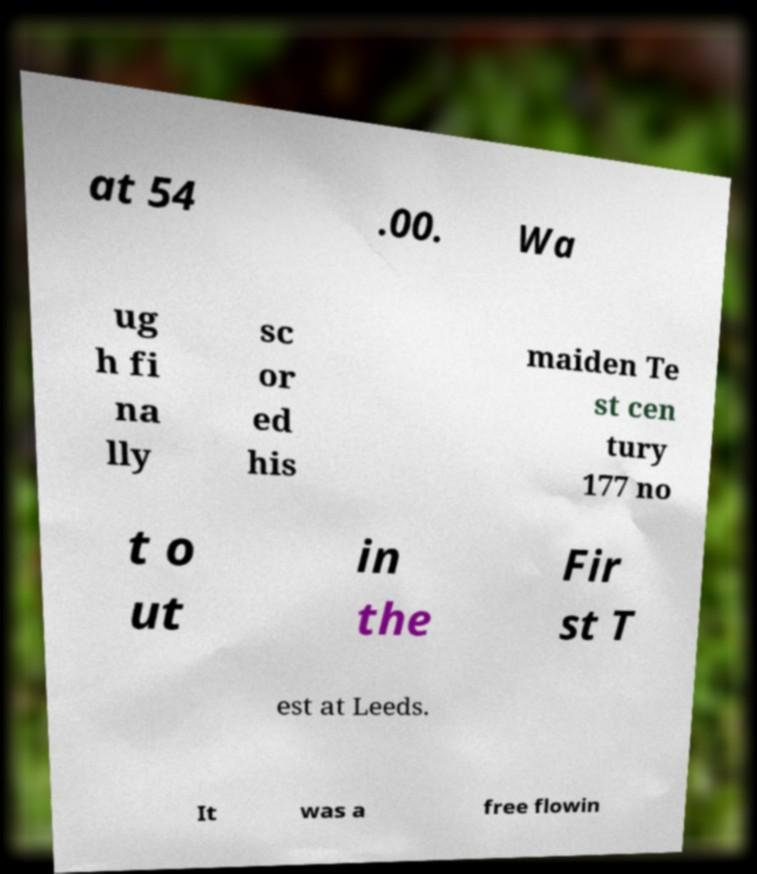There's text embedded in this image that I need extracted. Can you transcribe it verbatim? at 54 .00. Wa ug h fi na lly sc or ed his maiden Te st cen tury 177 no t o ut in the Fir st T est at Leeds. It was a free flowin 